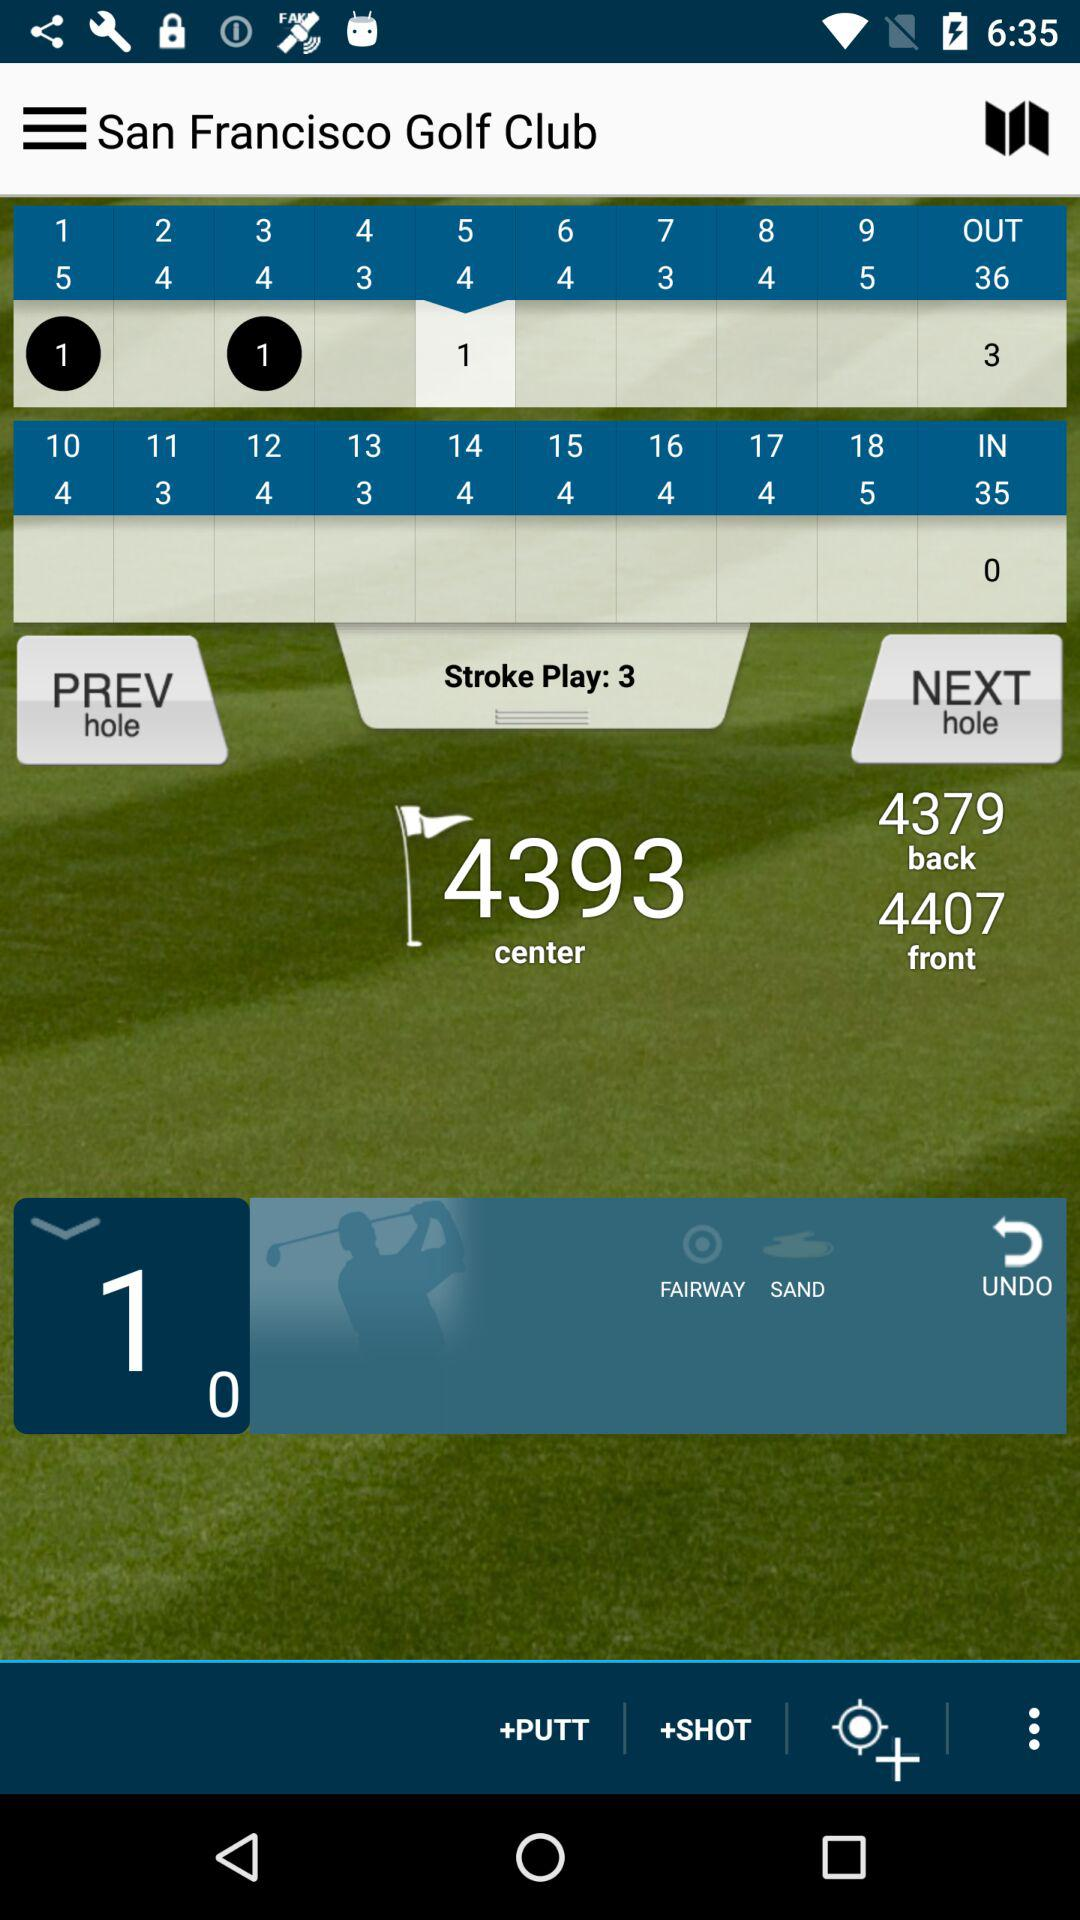What is the front score? The front score is 4407. 